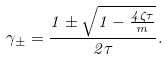Convert formula to latex. <formula><loc_0><loc_0><loc_500><loc_500>\gamma _ { \pm } = \frac { 1 \pm \sqrt { 1 - \frac { 4 \zeta \tau } { m } } } { 2 \tau } .</formula> 